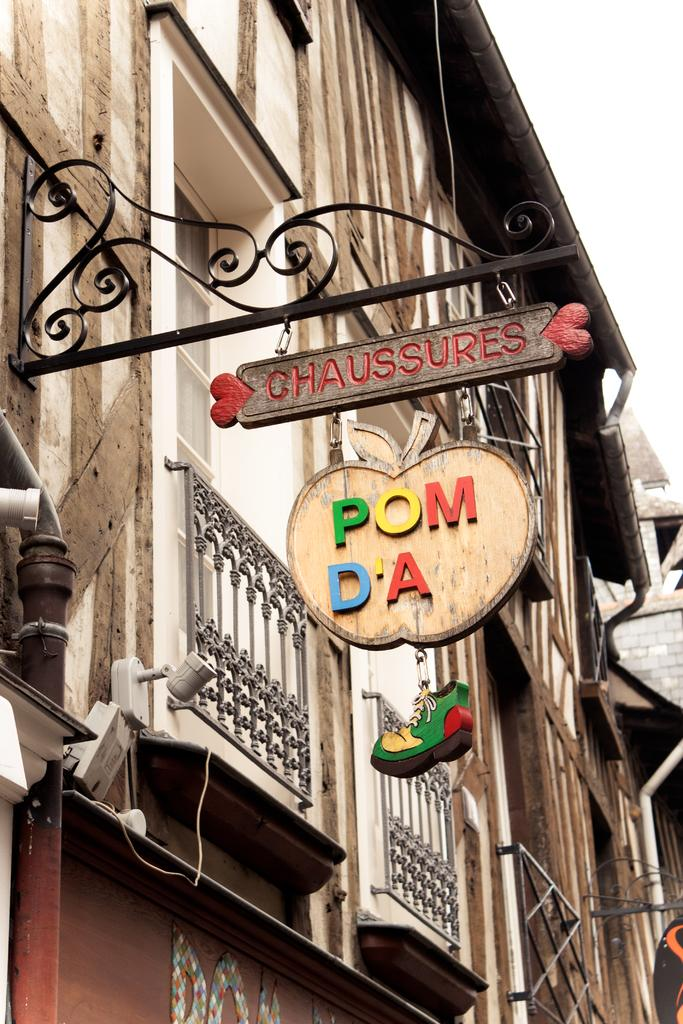<image>
Summarize the visual content of the image. A wooden hanging business sign that for Chaussures. 